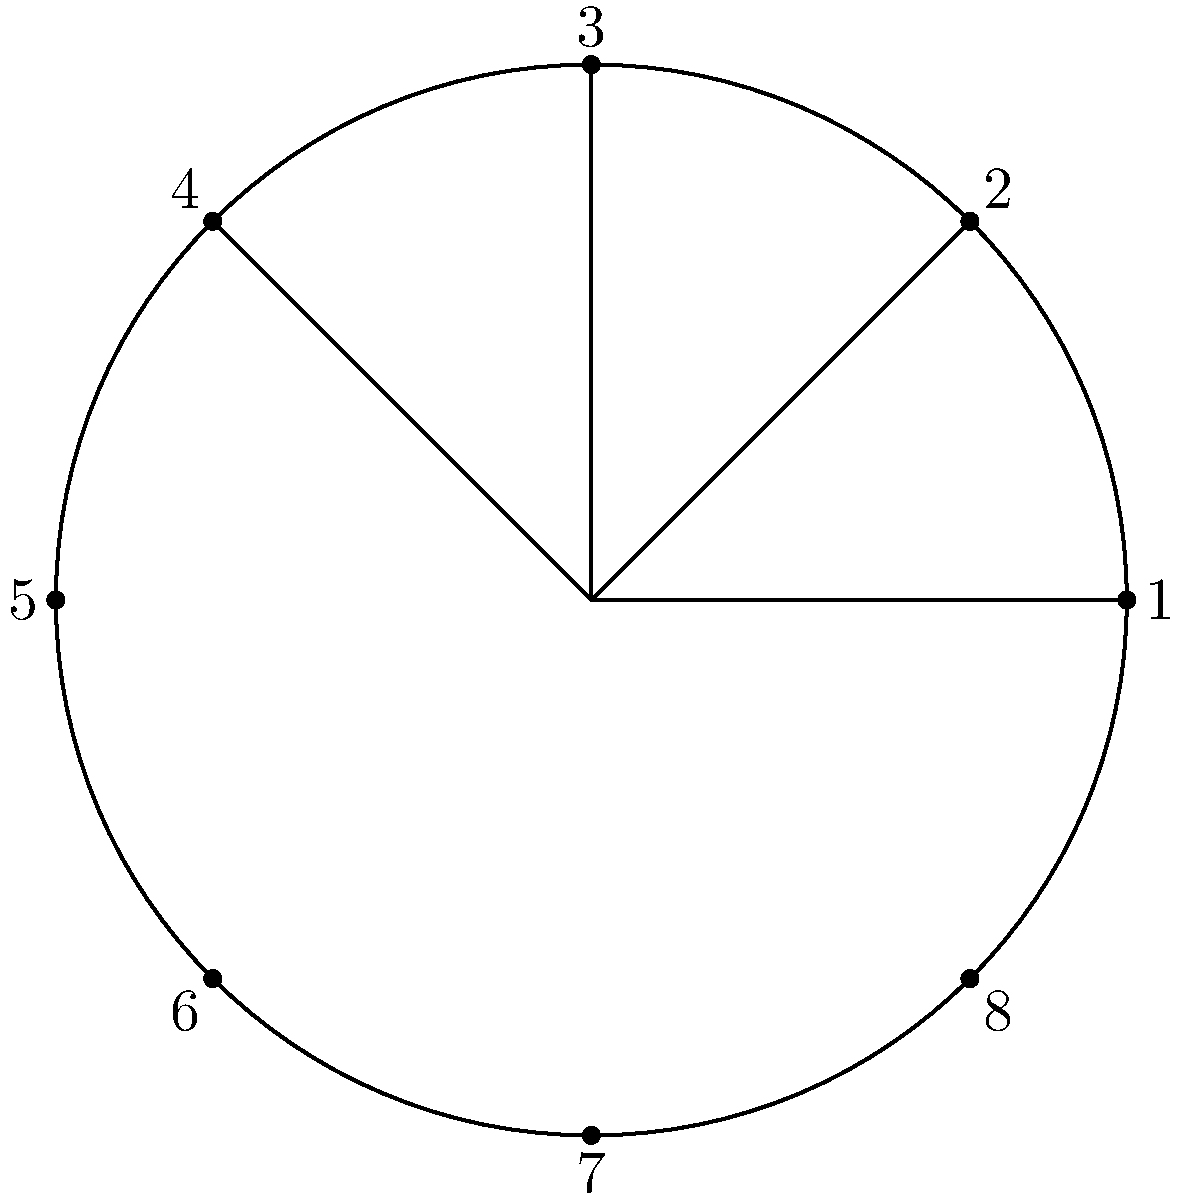In the dihedral group $D_8$, represented by symmetries of a regular octagon, what is the order of the element that rotates the octagon clockwise by 45°? How does this element relate to the concept of perseverance in group theory? To determine the order of the rotation element in $D_8$, we follow these steps:

1) The rotation by 45° clockwise is represented by $r$ in $D_8$.

2) We need to find the smallest positive integer $k$ such that $r^k = e$ (identity).

3) Let's apply the rotation repeatedly:
   $r^1$: rotates by 45°
   $r^2$: rotates by 90°
   $r^3$: rotates by 135°
   $r^4$: rotates by 180°
   $r^5$: rotates by 225°
   $r^6$: rotates by 270°
   $r^7$: rotates by 315°
   $r^8$: rotates by 360° (back to the starting position)

4) We see that $r^8 = e$, and this is the smallest such power.

5) Therefore, the order of $r$ is 8.

Relating to perseverance:
The concept of order in group theory demonstrates perseverance. Just as Marcial Arbiza might have valued determination in repeatedly applying a technique until mastery, in group theory, we persistently apply an operation (in this case, rotation) until we return to the starting point. This persistence in applying the operation embodies the spirit of determination, as we don't stop until we achieve our goal (returning to the identity).
Answer: 8 